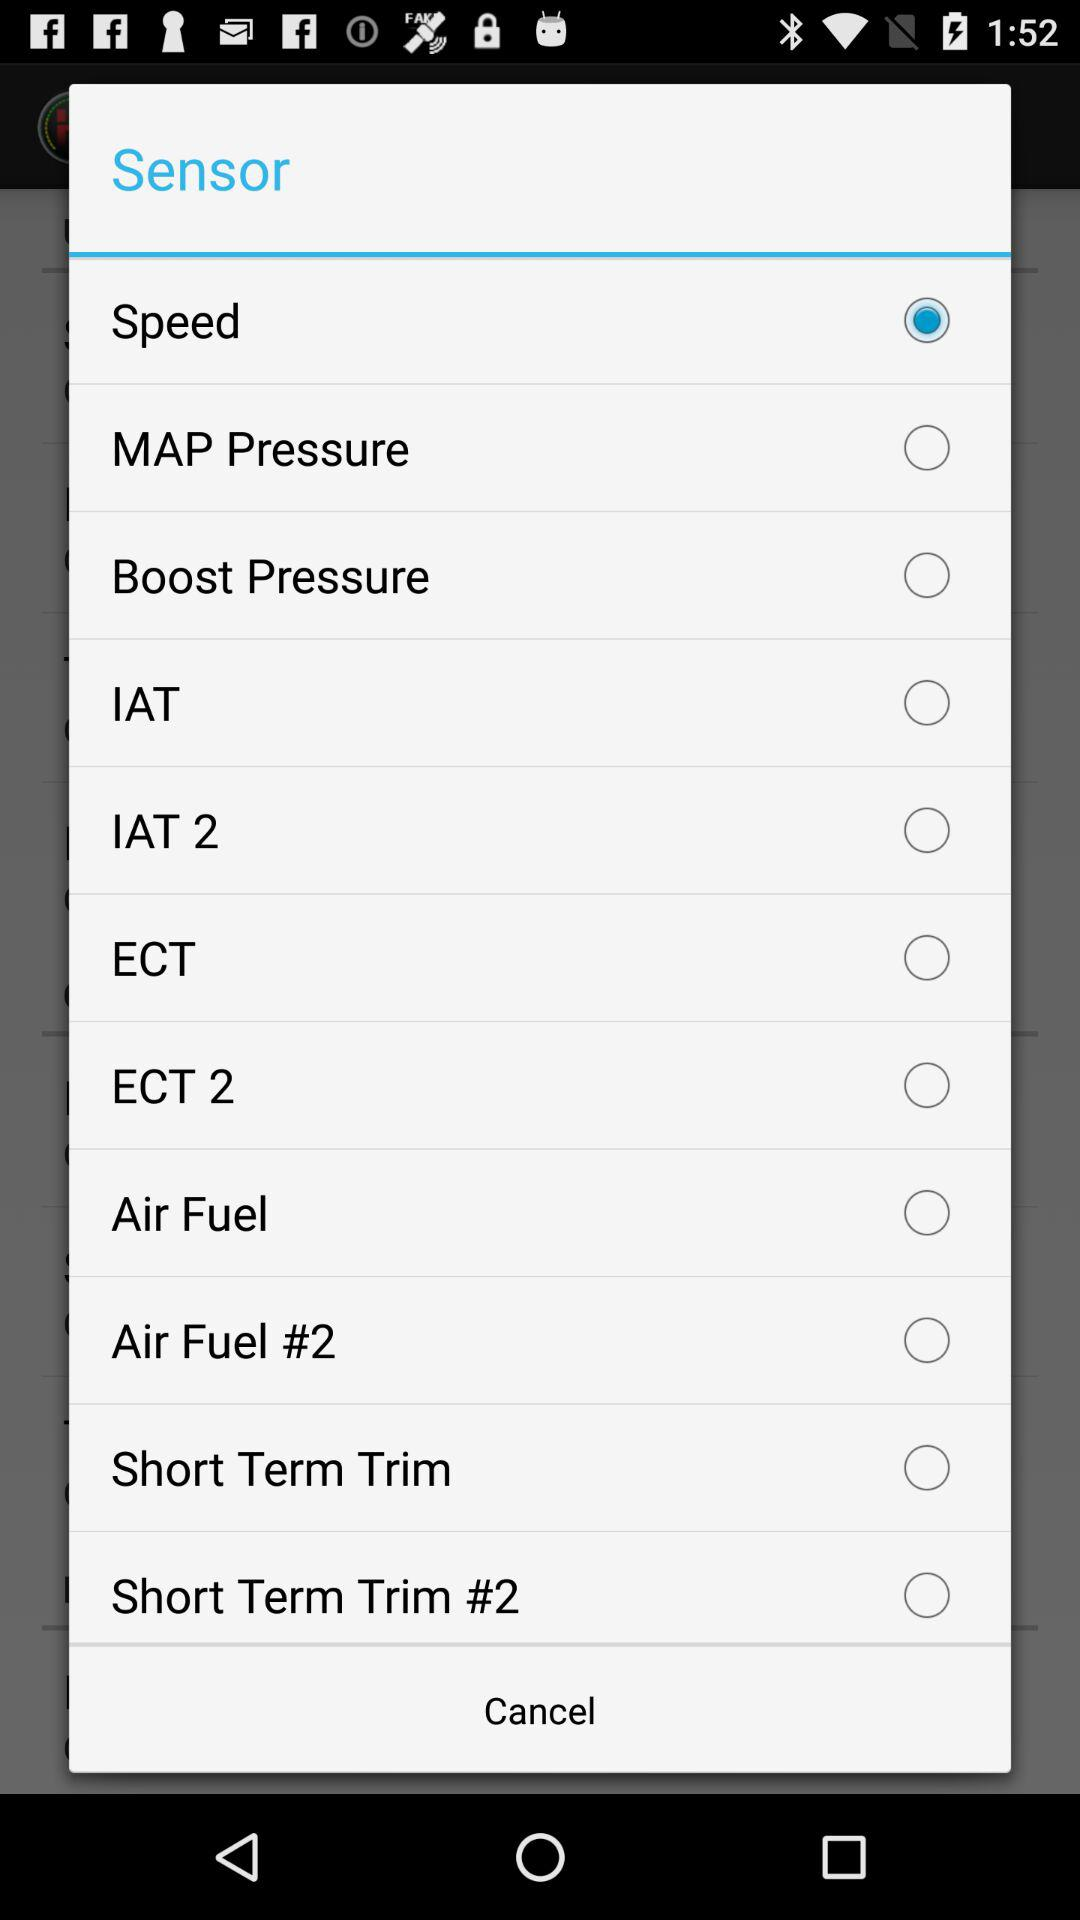Which option is selected? The selected option is "Speed". 